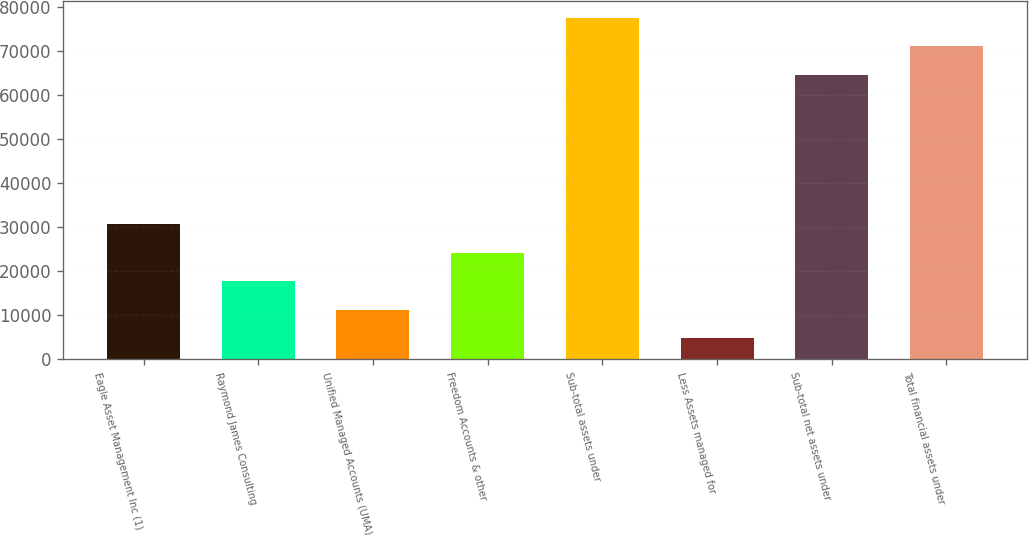<chart> <loc_0><loc_0><loc_500><loc_500><bar_chart><fcel>Eagle Asset Management Inc (1)<fcel>Raymond James Consulting<fcel>Unified Managed Accounts (UMA)<fcel>Freedom Accounts & other<fcel>Sub-total assets under<fcel>Less Assets managed for<fcel>Sub-total net assets under<fcel>Total financial assets under<nl><fcel>30633.8<fcel>17722.4<fcel>11266.7<fcel>24178.1<fcel>77468.4<fcel>4811<fcel>64557<fcel>71012.7<nl></chart> 